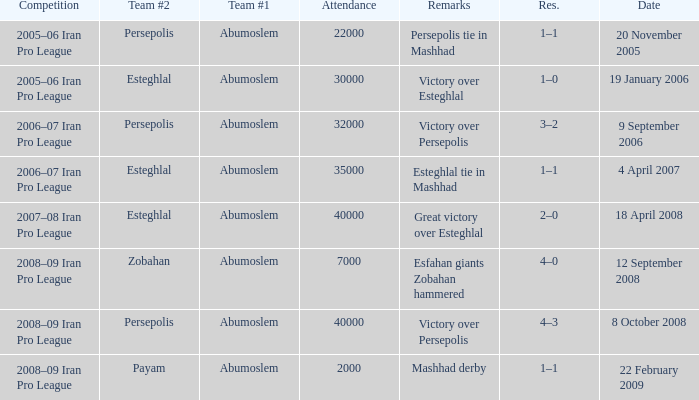What date was the attendance 22000? 20 November 2005. 